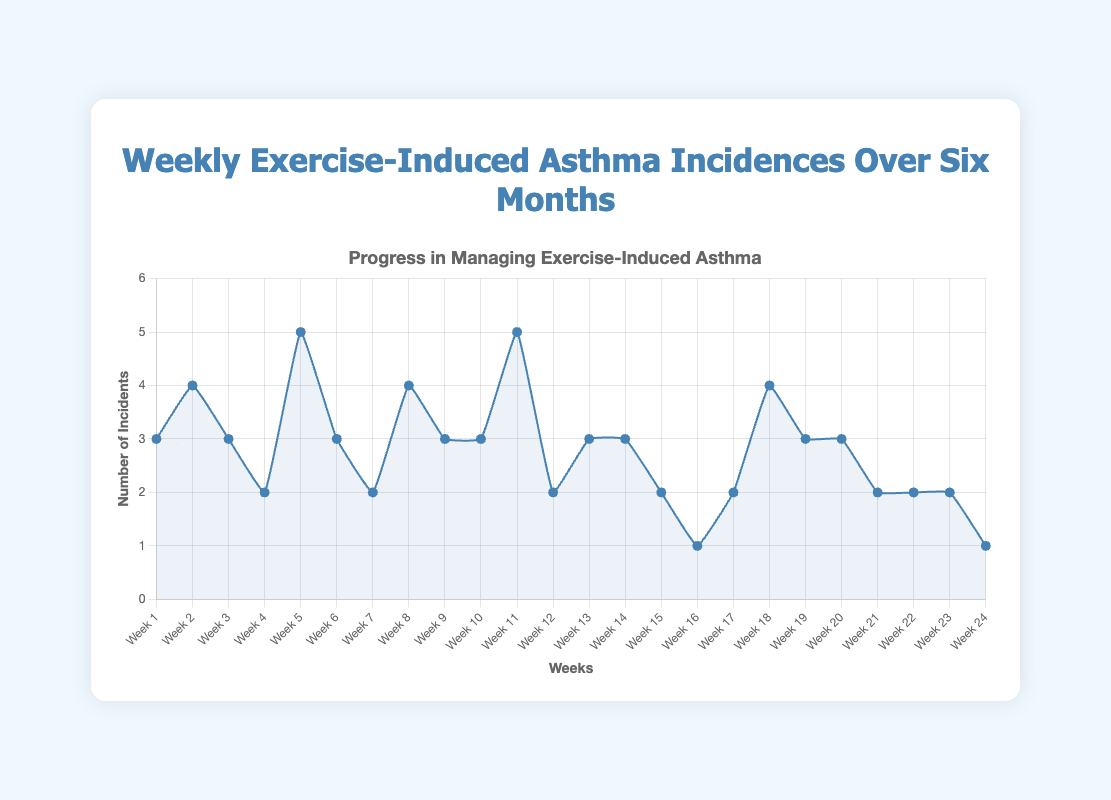What was the maximum number of exercise-induced asthma incidents in a single week? To find the maximum number of incidents, identify the highest value on the y-axis on the plot. The peak value of incidents occurs in Week 5 and Week 11, where the number of incidents is 5.
Answer: 5 In which week(s) did the asthma incidents reach their lowest? To determine the weeks with the lowest incidents, find the minimum value on the y-axis and check the corresponding week(s) on the x-axis. The lowest number of incidents, which is 1, occurred in Week 16 and Week 24.
Answer: Week 16, Week 24 What is the average number of exercise-induced asthma incidents per week over the six months? To find the average, sum up all the incidents over the 24 weeks and divide by 24. The total number of incidents is 70, so the average is 70/24 ≈ 2.92 incidents per week.
Answer: 2.92 How does the number of asthma incidents in Week 12 compare to Week 5? To compare, look at the y-axis values for both weeks. Week 5 has 5 incidents, while Week 12 has 2 incidents. Week 5 has 3 more incidents than Week 12.
Answer: Week 5 has 3 more incidents Over which consecutive two-week period was the total number of incidents the highest? To find the highest two-week total, sum incidents for all two consecutive weeks: Week 4-5 (2+5=7), Week 5-6 (5+3=8), ..., Week 23-24 (2+1=3). The highest total is 8 for Week 5-6 and Week 10-11.
Answer: Weeks 5-6 and Weeks 10-11 On average, did the number of asthma incidents decrease, increase, or remain stable over the six months? Evaluate the trend from the line plot. The overall number of incidents starts at 3 incidents in Week 1 and decreases to 1 incident in Week 24, indicating a general downward trend.
Answer: Decreased How many weeks recorded exactly 3 incidents of asthma? Count the occurrences where the y-axis value is exactly 3. These weeks are Week 1, Week 3, Week 9, Week 10, Week 13, Week 14, Week 19, and Week 20.
Answer: 8 weeks Is there a clear seasonal pattern or trend visible in the asthma incidents over the six months? Examine the line plot for any repeating patterns or trends. There isn't an obvious seasonal pattern, but there is a slight downward trend with incidents being more frequent initially and reducing towards the end.
Answer: No clear seasonal pattern, but slight downward trend 